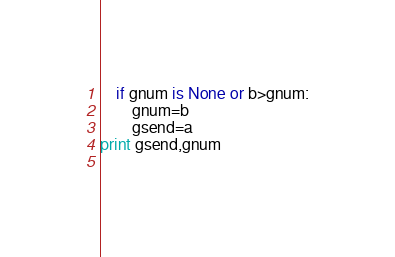Convert code to text. <code><loc_0><loc_0><loc_500><loc_500><_Python_>    if gnum is None or b>gnum:
        gnum=b
        gsend=a
print gsend,gnum
    </code> 